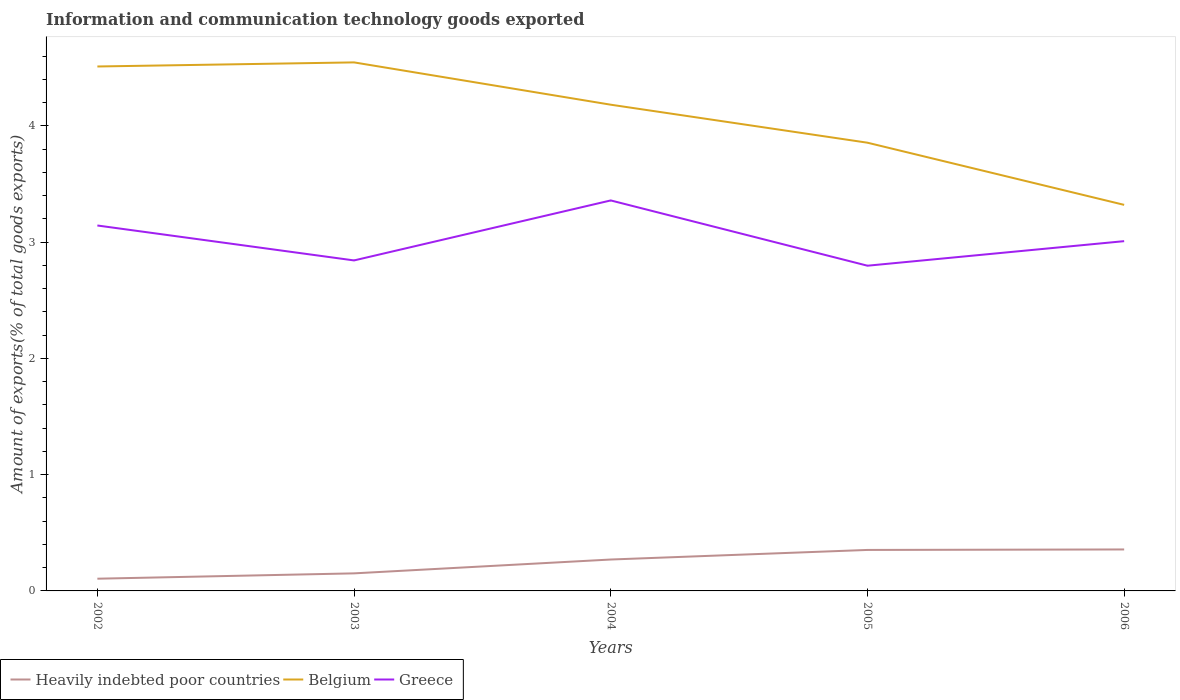Does the line corresponding to Heavily indebted poor countries intersect with the line corresponding to Greece?
Provide a succinct answer. No. Across all years, what is the maximum amount of goods exported in Heavily indebted poor countries?
Give a very brief answer. 0.11. What is the total amount of goods exported in Belgium in the graph?
Ensure brevity in your answer.  1.23. What is the difference between the highest and the second highest amount of goods exported in Greece?
Offer a very short reply. 0.56. What is the difference between the highest and the lowest amount of goods exported in Belgium?
Keep it short and to the point. 3. How many lines are there?
Ensure brevity in your answer.  3. How many years are there in the graph?
Give a very brief answer. 5. Does the graph contain any zero values?
Give a very brief answer. No. Where does the legend appear in the graph?
Offer a very short reply. Bottom left. How many legend labels are there?
Your answer should be compact. 3. How are the legend labels stacked?
Provide a short and direct response. Horizontal. What is the title of the graph?
Your answer should be very brief. Information and communication technology goods exported. Does "Latin America(developing only)" appear as one of the legend labels in the graph?
Keep it short and to the point. No. What is the label or title of the Y-axis?
Your response must be concise. Amount of exports(% of total goods exports). What is the Amount of exports(% of total goods exports) in Heavily indebted poor countries in 2002?
Offer a terse response. 0.11. What is the Amount of exports(% of total goods exports) of Belgium in 2002?
Your response must be concise. 4.51. What is the Amount of exports(% of total goods exports) in Greece in 2002?
Provide a short and direct response. 3.14. What is the Amount of exports(% of total goods exports) of Heavily indebted poor countries in 2003?
Provide a succinct answer. 0.15. What is the Amount of exports(% of total goods exports) in Belgium in 2003?
Offer a terse response. 4.55. What is the Amount of exports(% of total goods exports) in Greece in 2003?
Give a very brief answer. 2.84. What is the Amount of exports(% of total goods exports) of Heavily indebted poor countries in 2004?
Give a very brief answer. 0.27. What is the Amount of exports(% of total goods exports) of Belgium in 2004?
Your answer should be compact. 4.18. What is the Amount of exports(% of total goods exports) of Greece in 2004?
Keep it short and to the point. 3.36. What is the Amount of exports(% of total goods exports) in Heavily indebted poor countries in 2005?
Offer a terse response. 0.35. What is the Amount of exports(% of total goods exports) of Belgium in 2005?
Offer a terse response. 3.86. What is the Amount of exports(% of total goods exports) in Greece in 2005?
Keep it short and to the point. 2.8. What is the Amount of exports(% of total goods exports) of Heavily indebted poor countries in 2006?
Give a very brief answer. 0.36. What is the Amount of exports(% of total goods exports) in Belgium in 2006?
Offer a very short reply. 3.32. What is the Amount of exports(% of total goods exports) of Greece in 2006?
Your answer should be very brief. 3.01. Across all years, what is the maximum Amount of exports(% of total goods exports) of Heavily indebted poor countries?
Offer a terse response. 0.36. Across all years, what is the maximum Amount of exports(% of total goods exports) of Belgium?
Provide a short and direct response. 4.55. Across all years, what is the maximum Amount of exports(% of total goods exports) of Greece?
Your answer should be compact. 3.36. Across all years, what is the minimum Amount of exports(% of total goods exports) of Heavily indebted poor countries?
Ensure brevity in your answer.  0.11. Across all years, what is the minimum Amount of exports(% of total goods exports) in Belgium?
Ensure brevity in your answer.  3.32. Across all years, what is the minimum Amount of exports(% of total goods exports) in Greece?
Offer a very short reply. 2.8. What is the total Amount of exports(% of total goods exports) in Heavily indebted poor countries in the graph?
Provide a succinct answer. 1.24. What is the total Amount of exports(% of total goods exports) of Belgium in the graph?
Provide a short and direct response. 20.41. What is the total Amount of exports(% of total goods exports) of Greece in the graph?
Give a very brief answer. 15.15. What is the difference between the Amount of exports(% of total goods exports) of Heavily indebted poor countries in 2002 and that in 2003?
Provide a succinct answer. -0.05. What is the difference between the Amount of exports(% of total goods exports) in Belgium in 2002 and that in 2003?
Provide a succinct answer. -0.04. What is the difference between the Amount of exports(% of total goods exports) in Greece in 2002 and that in 2003?
Provide a succinct answer. 0.3. What is the difference between the Amount of exports(% of total goods exports) in Heavily indebted poor countries in 2002 and that in 2004?
Provide a succinct answer. -0.17. What is the difference between the Amount of exports(% of total goods exports) in Belgium in 2002 and that in 2004?
Make the answer very short. 0.33. What is the difference between the Amount of exports(% of total goods exports) in Greece in 2002 and that in 2004?
Make the answer very short. -0.22. What is the difference between the Amount of exports(% of total goods exports) of Heavily indebted poor countries in 2002 and that in 2005?
Offer a terse response. -0.25. What is the difference between the Amount of exports(% of total goods exports) in Belgium in 2002 and that in 2005?
Provide a succinct answer. 0.66. What is the difference between the Amount of exports(% of total goods exports) in Greece in 2002 and that in 2005?
Offer a very short reply. 0.35. What is the difference between the Amount of exports(% of total goods exports) in Heavily indebted poor countries in 2002 and that in 2006?
Your answer should be very brief. -0.25. What is the difference between the Amount of exports(% of total goods exports) in Belgium in 2002 and that in 2006?
Make the answer very short. 1.19. What is the difference between the Amount of exports(% of total goods exports) in Greece in 2002 and that in 2006?
Offer a very short reply. 0.13. What is the difference between the Amount of exports(% of total goods exports) in Heavily indebted poor countries in 2003 and that in 2004?
Offer a very short reply. -0.12. What is the difference between the Amount of exports(% of total goods exports) of Belgium in 2003 and that in 2004?
Give a very brief answer. 0.36. What is the difference between the Amount of exports(% of total goods exports) in Greece in 2003 and that in 2004?
Provide a succinct answer. -0.52. What is the difference between the Amount of exports(% of total goods exports) of Heavily indebted poor countries in 2003 and that in 2005?
Your answer should be compact. -0.2. What is the difference between the Amount of exports(% of total goods exports) of Belgium in 2003 and that in 2005?
Provide a short and direct response. 0.69. What is the difference between the Amount of exports(% of total goods exports) in Greece in 2003 and that in 2005?
Your response must be concise. 0.05. What is the difference between the Amount of exports(% of total goods exports) in Heavily indebted poor countries in 2003 and that in 2006?
Give a very brief answer. -0.21. What is the difference between the Amount of exports(% of total goods exports) in Belgium in 2003 and that in 2006?
Your answer should be compact. 1.23. What is the difference between the Amount of exports(% of total goods exports) in Greece in 2003 and that in 2006?
Provide a short and direct response. -0.17. What is the difference between the Amount of exports(% of total goods exports) of Heavily indebted poor countries in 2004 and that in 2005?
Your answer should be very brief. -0.08. What is the difference between the Amount of exports(% of total goods exports) in Belgium in 2004 and that in 2005?
Offer a terse response. 0.33. What is the difference between the Amount of exports(% of total goods exports) of Greece in 2004 and that in 2005?
Offer a terse response. 0.56. What is the difference between the Amount of exports(% of total goods exports) in Heavily indebted poor countries in 2004 and that in 2006?
Offer a terse response. -0.09. What is the difference between the Amount of exports(% of total goods exports) in Belgium in 2004 and that in 2006?
Give a very brief answer. 0.86. What is the difference between the Amount of exports(% of total goods exports) of Greece in 2004 and that in 2006?
Offer a terse response. 0.35. What is the difference between the Amount of exports(% of total goods exports) of Heavily indebted poor countries in 2005 and that in 2006?
Offer a terse response. -0. What is the difference between the Amount of exports(% of total goods exports) of Belgium in 2005 and that in 2006?
Your answer should be very brief. 0.53. What is the difference between the Amount of exports(% of total goods exports) of Greece in 2005 and that in 2006?
Make the answer very short. -0.21. What is the difference between the Amount of exports(% of total goods exports) in Heavily indebted poor countries in 2002 and the Amount of exports(% of total goods exports) in Belgium in 2003?
Your response must be concise. -4.44. What is the difference between the Amount of exports(% of total goods exports) in Heavily indebted poor countries in 2002 and the Amount of exports(% of total goods exports) in Greece in 2003?
Make the answer very short. -2.74. What is the difference between the Amount of exports(% of total goods exports) of Belgium in 2002 and the Amount of exports(% of total goods exports) of Greece in 2003?
Offer a terse response. 1.67. What is the difference between the Amount of exports(% of total goods exports) of Heavily indebted poor countries in 2002 and the Amount of exports(% of total goods exports) of Belgium in 2004?
Provide a succinct answer. -4.08. What is the difference between the Amount of exports(% of total goods exports) in Heavily indebted poor countries in 2002 and the Amount of exports(% of total goods exports) in Greece in 2004?
Offer a terse response. -3.25. What is the difference between the Amount of exports(% of total goods exports) of Belgium in 2002 and the Amount of exports(% of total goods exports) of Greece in 2004?
Provide a short and direct response. 1.15. What is the difference between the Amount of exports(% of total goods exports) of Heavily indebted poor countries in 2002 and the Amount of exports(% of total goods exports) of Belgium in 2005?
Offer a terse response. -3.75. What is the difference between the Amount of exports(% of total goods exports) of Heavily indebted poor countries in 2002 and the Amount of exports(% of total goods exports) of Greece in 2005?
Make the answer very short. -2.69. What is the difference between the Amount of exports(% of total goods exports) of Belgium in 2002 and the Amount of exports(% of total goods exports) of Greece in 2005?
Your answer should be compact. 1.71. What is the difference between the Amount of exports(% of total goods exports) in Heavily indebted poor countries in 2002 and the Amount of exports(% of total goods exports) in Belgium in 2006?
Your answer should be very brief. -3.22. What is the difference between the Amount of exports(% of total goods exports) in Heavily indebted poor countries in 2002 and the Amount of exports(% of total goods exports) in Greece in 2006?
Give a very brief answer. -2.9. What is the difference between the Amount of exports(% of total goods exports) in Belgium in 2002 and the Amount of exports(% of total goods exports) in Greece in 2006?
Ensure brevity in your answer.  1.5. What is the difference between the Amount of exports(% of total goods exports) in Heavily indebted poor countries in 2003 and the Amount of exports(% of total goods exports) in Belgium in 2004?
Provide a short and direct response. -4.03. What is the difference between the Amount of exports(% of total goods exports) of Heavily indebted poor countries in 2003 and the Amount of exports(% of total goods exports) of Greece in 2004?
Your answer should be compact. -3.21. What is the difference between the Amount of exports(% of total goods exports) of Belgium in 2003 and the Amount of exports(% of total goods exports) of Greece in 2004?
Give a very brief answer. 1.19. What is the difference between the Amount of exports(% of total goods exports) of Heavily indebted poor countries in 2003 and the Amount of exports(% of total goods exports) of Belgium in 2005?
Provide a short and direct response. -3.7. What is the difference between the Amount of exports(% of total goods exports) of Heavily indebted poor countries in 2003 and the Amount of exports(% of total goods exports) of Greece in 2005?
Give a very brief answer. -2.65. What is the difference between the Amount of exports(% of total goods exports) of Belgium in 2003 and the Amount of exports(% of total goods exports) of Greece in 2005?
Make the answer very short. 1.75. What is the difference between the Amount of exports(% of total goods exports) of Heavily indebted poor countries in 2003 and the Amount of exports(% of total goods exports) of Belgium in 2006?
Offer a very short reply. -3.17. What is the difference between the Amount of exports(% of total goods exports) of Heavily indebted poor countries in 2003 and the Amount of exports(% of total goods exports) of Greece in 2006?
Offer a terse response. -2.86. What is the difference between the Amount of exports(% of total goods exports) of Belgium in 2003 and the Amount of exports(% of total goods exports) of Greece in 2006?
Your answer should be very brief. 1.54. What is the difference between the Amount of exports(% of total goods exports) of Heavily indebted poor countries in 2004 and the Amount of exports(% of total goods exports) of Belgium in 2005?
Provide a short and direct response. -3.58. What is the difference between the Amount of exports(% of total goods exports) in Heavily indebted poor countries in 2004 and the Amount of exports(% of total goods exports) in Greece in 2005?
Your answer should be compact. -2.53. What is the difference between the Amount of exports(% of total goods exports) of Belgium in 2004 and the Amount of exports(% of total goods exports) of Greece in 2005?
Give a very brief answer. 1.38. What is the difference between the Amount of exports(% of total goods exports) in Heavily indebted poor countries in 2004 and the Amount of exports(% of total goods exports) in Belgium in 2006?
Your response must be concise. -3.05. What is the difference between the Amount of exports(% of total goods exports) of Heavily indebted poor countries in 2004 and the Amount of exports(% of total goods exports) of Greece in 2006?
Ensure brevity in your answer.  -2.74. What is the difference between the Amount of exports(% of total goods exports) in Belgium in 2004 and the Amount of exports(% of total goods exports) in Greece in 2006?
Keep it short and to the point. 1.17. What is the difference between the Amount of exports(% of total goods exports) of Heavily indebted poor countries in 2005 and the Amount of exports(% of total goods exports) of Belgium in 2006?
Your answer should be very brief. -2.97. What is the difference between the Amount of exports(% of total goods exports) of Heavily indebted poor countries in 2005 and the Amount of exports(% of total goods exports) of Greece in 2006?
Keep it short and to the point. -2.66. What is the difference between the Amount of exports(% of total goods exports) of Belgium in 2005 and the Amount of exports(% of total goods exports) of Greece in 2006?
Provide a short and direct response. 0.85. What is the average Amount of exports(% of total goods exports) in Heavily indebted poor countries per year?
Ensure brevity in your answer.  0.25. What is the average Amount of exports(% of total goods exports) of Belgium per year?
Make the answer very short. 4.08. What is the average Amount of exports(% of total goods exports) of Greece per year?
Provide a succinct answer. 3.03. In the year 2002, what is the difference between the Amount of exports(% of total goods exports) of Heavily indebted poor countries and Amount of exports(% of total goods exports) of Belgium?
Give a very brief answer. -4.41. In the year 2002, what is the difference between the Amount of exports(% of total goods exports) in Heavily indebted poor countries and Amount of exports(% of total goods exports) in Greece?
Keep it short and to the point. -3.04. In the year 2002, what is the difference between the Amount of exports(% of total goods exports) of Belgium and Amount of exports(% of total goods exports) of Greece?
Make the answer very short. 1.37. In the year 2003, what is the difference between the Amount of exports(% of total goods exports) of Heavily indebted poor countries and Amount of exports(% of total goods exports) of Belgium?
Provide a succinct answer. -4.39. In the year 2003, what is the difference between the Amount of exports(% of total goods exports) in Heavily indebted poor countries and Amount of exports(% of total goods exports) in Greece?
Make the answer very short. -2.69. In the year 2003, what is the difference between the Amount of exports(% of total goods exports) of Belgium and Amount of exports(% of total goods exports) of Greece?
Your answer should be compact. 1.7. In the year 2004, what is the difference between the Amount of exports(% of total goods exports) of Heavily indebted poor countries and Amount of exports(% of total goods exports) of Belgium?
Provide a succinct answer. -3.91. In the year 2004, what is the difference between the Amount of exports(% of total goods exports) in Heavily indebted poor countries and Amount of exports(% of total goods exports) in Greece?
Your answer should be compact. -3.09. In the year 2004, what is the difference between the Amount of exports(% of total goods exports) of Belgium and Amount of exports(% of total goods exports) of Greece?
Make the answer very short. 0.82. In the year 2005, what is the difference between the Amount of exports(% of total goods exports) of Heavily indebted poor countries and Amount of exports(% of total goods exports) of Belgium?
Offer a very short reply. -3.5. In the year 2005, what is the difference between the Amount of exports(% of total goods exports) of Heavily indebted poor countries and Amount of exports(% of total goods exports) of Greece?
Provide a short and direct response. -2.44. In the year 2005, what is the difference between the Amount of exports(% of total goods exports) of Belgium and Amount of exports(% of total goods exports) of Greece?
Provide a short and direct response. 1.06. In the year 2006, what is the difference between the Amount of exports(% of total goods exports) in Heavily indebted poor countries and Amount of exports(% of total goods exports) in Belgium?
Ensure brevity in your answer.  -2.96. In the year 2006, what is the difference between the Amount of exports(% of total goods exports) in Heavily indebted poor countries and Amount of exports(% of total goods exports) in Greece?
Make the answer very short. -2.65. In the year 2006, what is the difference between the Amount of exports(% of total goods exports) in Belgium and Amount of exports(% of total goods exports) in Greece?
Offer a very short reply. 0.31. What is the ratio of the Amount of exports(% of total goods exports) in Heavily indebted poor countries in 2002 to that in 2003?
Offer a terse response. 0.7. What is the ratio of the Amount of exports(% of total goods exports) in Greece in 2002 to that in 2003?
Offer a terse response. 1.11. What is the ratio of the Amount of exports(% of total goods exports) in Heavily indebted poor countries in 2002 to that in 2004?
Give a very brief answer. 0.39. What is the ratio of the Amount of exports(% of total goods exports) in Belgium in 2002 to that in 2004?
Give a very brief answer. 1.08. What is the ratio of the Amount of exports(% of total goods exports) in Greece in 2002 to that in 2004?
Offer a very short reply. 0.94. What is the ratio of the Amount of exports(% of total goods exports) in Heavily indebted poor countries in 2002 to that in 2005?
Offer a terse response. 0.3. What is the ratio of the Amount of exports(% of total goods exports) of Belgium in 2002 to that in 2005?
Your response must be concise. 1.17. What is the ratio of the Amount of exports(% of total goods exports) in Greece in 2002 to that in 2005?
Your answer should be very brief. 1.12. What is the ratio of the Amount of exports(% of total goods exports) in Heavily indebted poor countries in 2002 to that in 2006?
Provide a succinct answer. 0.29. What is the ratio of the Amount of exports(% of total goods exports) in Belgium in 2002 to that in 2006?
Offer a very short reply. 1.36. What is the ratio of the Amount of exports(% of total goods exports) of Greece in 2002 to that in 2006?
Ensure brevity in your answer.  1.04. What is the ratio of the Amount of exports(% of total goods exports) in Heavily indebted poor countries in 2003 to that in 2004?
Keep it short and to the point. 0.56. What is the ratio of the Amount of exports(% of total goods exports) of Belgium in 2003 to that in 2004?
Make the answer very short. 1.09. What is the ratio of the Amount of exports(% of total goods exports) in Greece in 2003 to that in 2004?
Provide a short and direct response. 0.85. What is the ratio of the Amount of exports(% of total goods exports) of Heavily indebted poor countries in 2003 to that in 2005?
Give a very brief answer. 0.43. What is the ratio of the Amount of exports(% of total goods exports) of Belgium in 2003 to that in 2005?
Give a very brief answer. 1.18. What is the ratio of the Amount of exports(% of total goods exports) in Greece in 2003 to that in 2005?
Make the answer very short. 1.02. What is the ratio of the Amount of exports(% of total goods exports) of Heavily indebted poor countries in 2003 to that in 2006?
Your answer should be compact. 0.42. What is the ratio of the Amount of exports(% of total goods exports) in Belgium in 2003 to that in 2006?
Offer a very short reply. 1.37. What is the ratio of the Amount of exports(% of total goods exports) of Greece in 2003 to that in 2006?
Make the answer very short. 0.94. What is the ratio of the Amount of exports(% of total goods exports) in Heavily indebted poor countries in 2004 to that in 2005?
Provide a succinct answer. 0.77. What is the ratio of the Amount of exports(% of total goods exports) of Belgium in 2004 to that in 2005?
Offer a terse response. 1.08. What is the ratio of the Amount of exports(% of total goods exports) in Greece in 2004 to that in 2005?
Keep it short and to the point. 1.2. What is the ratio of the Amount of exports(% of total goods exports) in Heavily indebted poor countries in 2004 to that in 2006?
Offer a very short reply. 0.76. What is the ratio of the Amount of exports(% of total goods exports) of Belgium in 2004 to that in 2006?
Provide a succinct answer. 1.26. What is the ratio of the Amount of exports(% of total goods exports) in Greece in 2004 to that in 2006?
Offer a terse response. 1.12. What is the ratio of the Amount of exports(% of total goods exports) in Belgium in 2005 to that in 2006?
Offer a very short reply. 1.16. What is the ratio of the Amount of exports(% of total goods exports) of Greece in 2005 to that in 2006?
Your answer should be compact. 0.93. What is the difference between the highest and the second highest Amount of exports(% of total goods exports) of Heavily indebted poor countries?
Keep it short and to the point. 0. What is the difference between the highest and the second highest Amount of exports(% of total goods exports) in Belgium?
Ensure brevity in your answer.  0.04. What is the difference between the highest and the second highest Amount of exports(% of total goods exports) in Greece?
Your answer should be compact. 0.22. What is the difference between the highest and the lowest Amount of exports(% of total goods exports) of Heavily indebted poor countries?
Your answer should be compact. 0.25. What is the difference between the highest and the lowest Amount of exports(% of total goods exports) of Belgium?
Provide a short and direct response. 1.23. What is the difference between the highest and the lowest Amount of exports(% of total goods exports) in Greece?
Give a very brief answer. 0.56. 